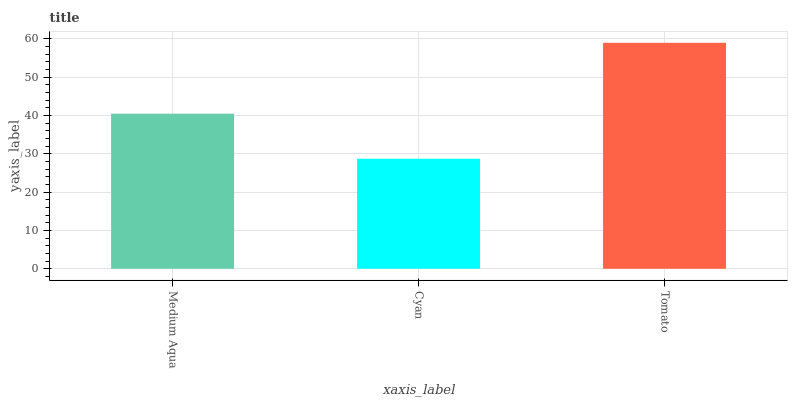Is Cyan the minimum?
Answer yes or no. Yes. Is Tomato the maximum?
Answer yes or no. Yes. Is Tomato the minimum?
Answer yes or no. No. Is Cyan the maximum?
Answer yes or no. No. Is Tomato greater than Cyan?
Answer yes or no. Yes. Is Cyan less than Tomato?
Answer yes or no. Yes. Is Cyan greater than Tomato?
Answer yes or no. No. Is Tomato less than Cyan?
Answer yes or no. No. Is Medium Aqua the high median?
Answer yes or no. Yes. Is Medium Aqua the low median?
Answer yes or no. Yes. Is Tomato the high median?
Answer yes or no. No. Is Tomato the low median?
Answer yes or no. No. 